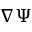Convert formula to latex. <formula><loc_0><loc_0><loc_500><loc_500>\nabla \Psi</formula> 